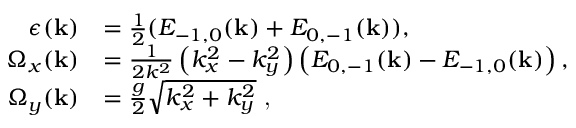Convert formula to latex. <formula><loc_0><loc_0><loc_500><loc_500>\begin{array} { r l } { \epsilon ( k ) } & { = \frac { 1 } { 2 } ( E _ { - 1 , 0 } ( k ) + E _ { 0 , - 1 } ( k ) ) , } \\ { \Omega _ { x } ( k ) } & { = \frac { 1 } { 2 k ^ { 2 } } \left ( k _ { x } ^ { 2 } - k _ { y } ^ { 2 } \right ) \left ( E _ { 0 , - 1 } ( k ) - E _ { - 1 , 0 } ( k ) \right ) , } \\ { \Omega _ { y } ( k ) } & { = \frac { g } { 2 } \sqrt { k _ { x } ^ { 2 } + k _ { y } ^ { 2 } } , } \end{array}</formula> 